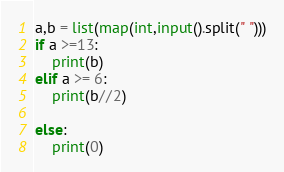<code> <loc_0><loc_0><loc_500><loc_500><_Python_>a,b = list(map(int,input().split(" ")))
if a >=13:
    print(b)
elif a >= 6:
    print(b//2)

else:
    print(0)</code> 